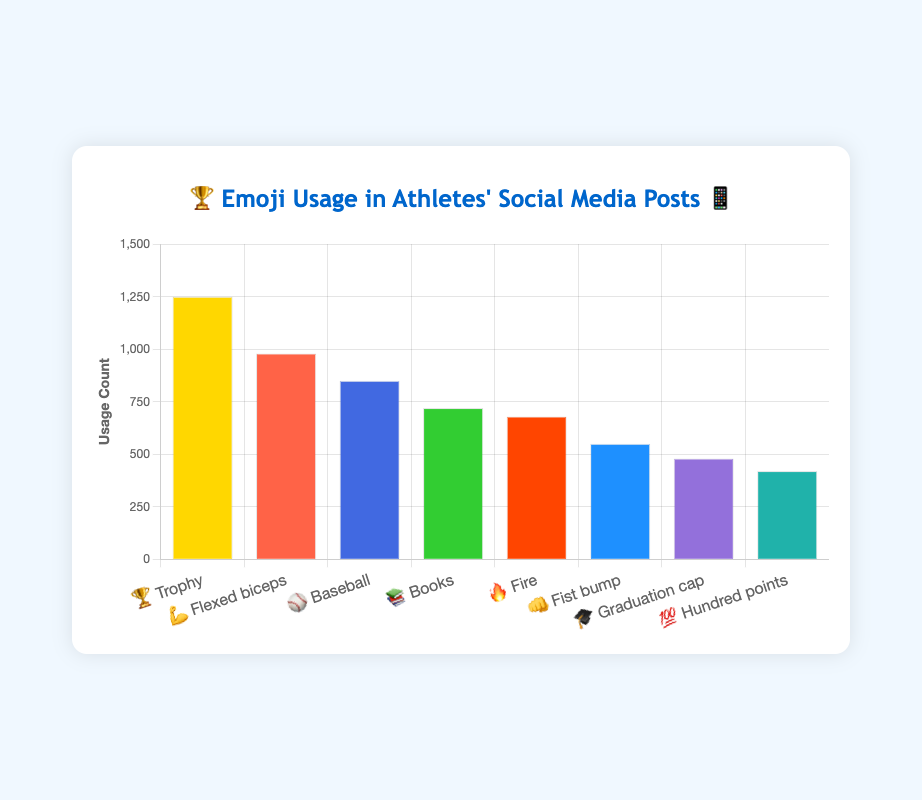Which emoji has the highest usage count? The emoji with the highest bar in the chart is 🏆 Trophy with 1250 usage count.
Answer: 🏆 Trophy What is the total usage count of 🏆 Trophy and 💪 Flexed biceps? The count for 🏆 Trophy is 1250 and for 💪 Flexed biceps is 980. Adding these together gives 1250 + 980 = 2230.
Answer: 2230 Which emoji representing a physical activity has the lowest usage count? The emojis representing physical activities include 🏆 Trophy, 💪 Flexed biceps, ⚾ Baseball, and 👊 Fist bump. The one with the lowest usage count among these is 👊 Fist bump with 550.
Answer: 👊 Fist bump How does the usage count of 📚 Books compare to 🎓 Graduation cap? The usage count of 📚 Books is 720 and 🎓 Graduation cap is 480. Since 720 > 480, 📚 Books is used more frequently than 🎓 Graduation cap.
Answer: 📚 Books What is the average usage count of all emojis combined? The total usage count is 1250 (🏆) + 980 (💪) + 850 (⚾) + 720 (📚) + 680 (🔥) + 550 (👊) + 480 (🎓) + 420 (💯) = 5930. There are 8 emojis, so the average is 5930 / 8 = 741.25.
Answer: 741.25 Which emoji's usage count is closest to the median usage count? Listing the counts in ascending order: 420, 480, 550, 680, 720, 850, 980, 1250. The median (average of 4th and 5th elements) is (680 + 720) / 2 = 700. 📚 Books, with 720, is closest to this value.
Answer: 📚 Books How does the usage of 💯 Hundred points compare to 🔥 Fire? The count for 💯 Hundred points is 420 and for 🔥 Fire is 680. Since 420 < 680, 🔥 Fire is used more frequently than 💯 Hundred points.
Answer: 🔥 Fire What is the combined usage count of emojis related to education 📚 and 🎓? The count for 📚 Books is 720 and for 🎓 Graduation cap is 480. Adding these together gives 720 + 480 = 1200.
Answer: 1200 How many emojis have a usage count of 550 or above? The emojis with a usage count of 550 or above are 🏆 Trophy (1250), 💪 Flexed biceps (980), ⚾ Baseball (850), 📚 Books (720), 🔥 Fire (680), and 👊 Fist bump (550). This totals to 6 emojis.
Answer: 6 What is the ratio of the usage of 🏆 Trophy to ⚾ Baseball? The count for 🏆 Trophy is 1250 and for ⚾ Baseball is 850. The ratio is 1250 / 850 = 1.47 (approximately).
Answer: 1.47 